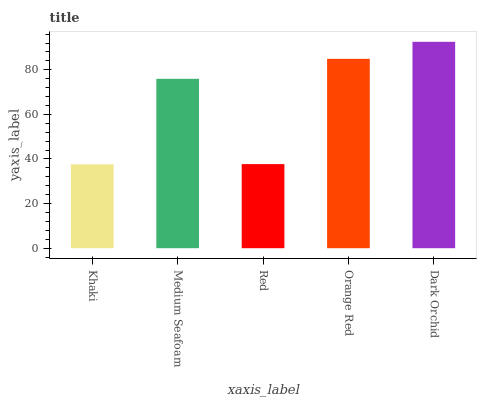Is Khaki the minimum?
Answer yes or no. Yes. Is Dark Orchid the maximum?
Answer yes or no. Yes. Is Medium Seafoam the minimum?
Answer yes or no. No. Is Medium Seafoam the maximum?
Answer yes or no. No. Is Medium Seafoam greater than Khaki?
Answer yes or no. Yes. Is Khaki less than Medium Seafoam?
Answer yes or no. Yes. Is Khaki greater than Medium Seafoam?
Answer yes or no. No. Is Medium Seafoam less than Khaki?
Answer yes or no. No. Is Medium Seafoam the high median?
Answer yes or no. Yes. Is Medium Seafoam the low median?
Answer yes or no. Yes. Is Dark Orchid the high median?
Answer yes or no. No. Is Khaki the low median?
Answer yes or no. No. 